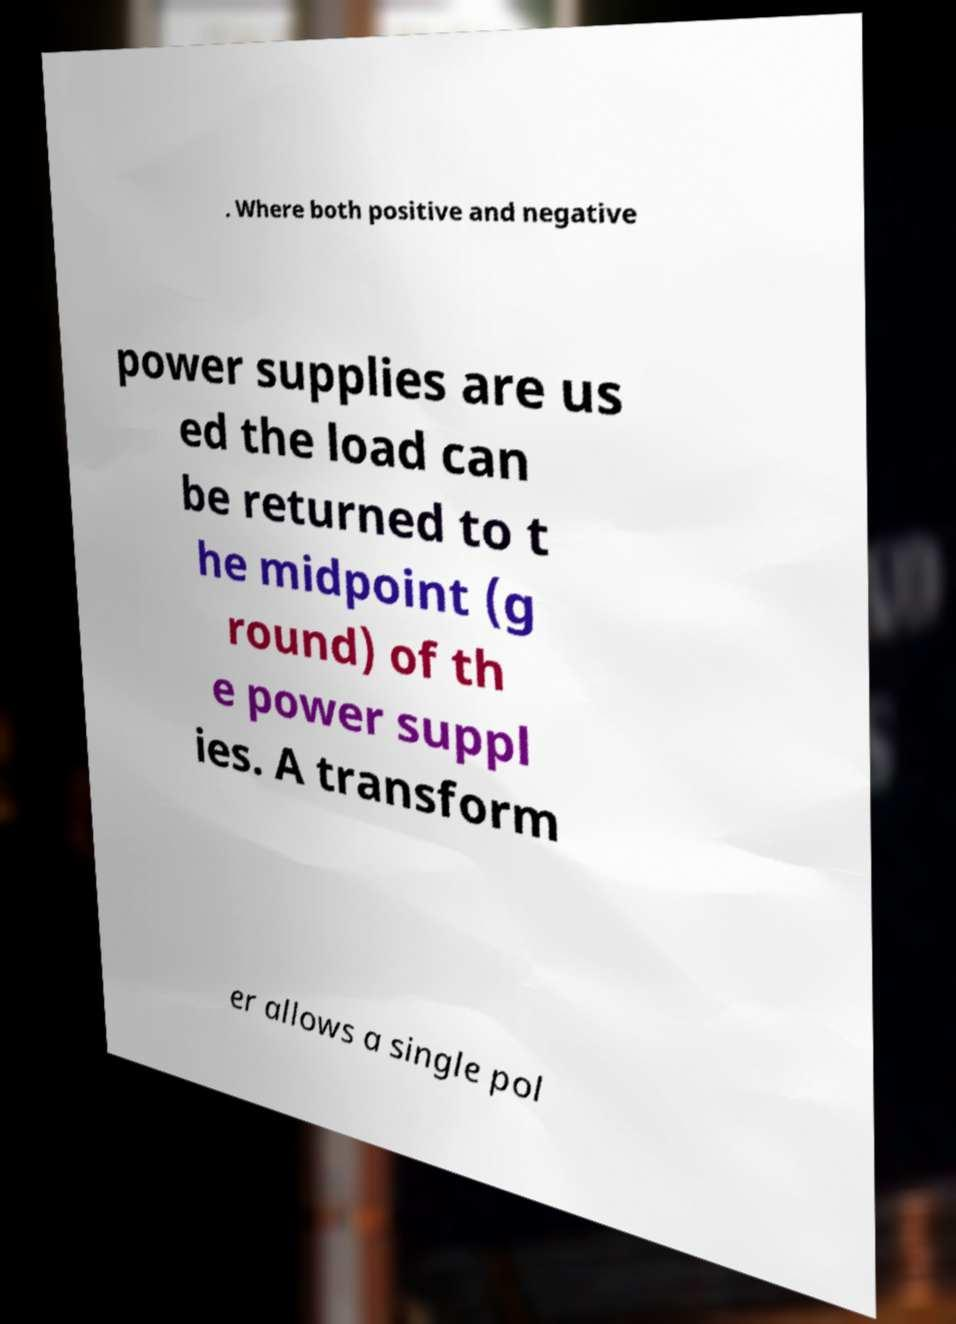Please identify and transcribe the text found in this image. . Where both positive and negative power supplies are us ed the load can be returned to t he midpoint (g round) of th e power suppl ies. A transform er allows a single pol 